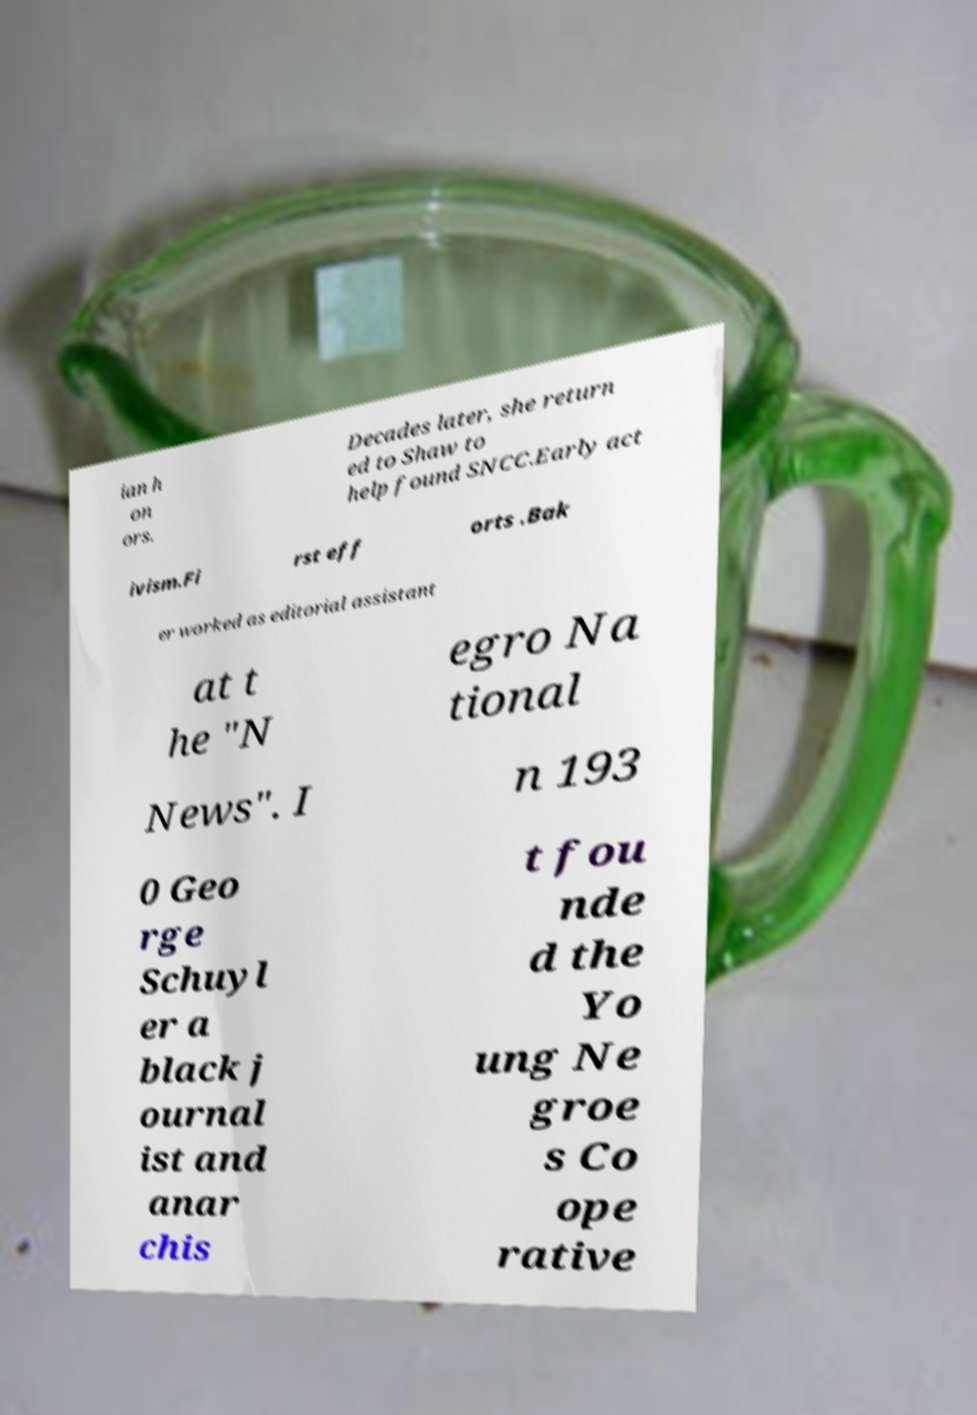Can you accurately transcribe the text from the provided image for me? ian h on ors. Decades later, she return ed to Shaw to help found SNCC.Early act ivism.Fi rst eff orts .Bak er worked as editorial assistant at t he "N egro Na tional News". I n 193 0 Geo rge Schuyl er a black j ournal ist and anar chis t fou nde d the Yo ung Ne groe s Co ope rative 